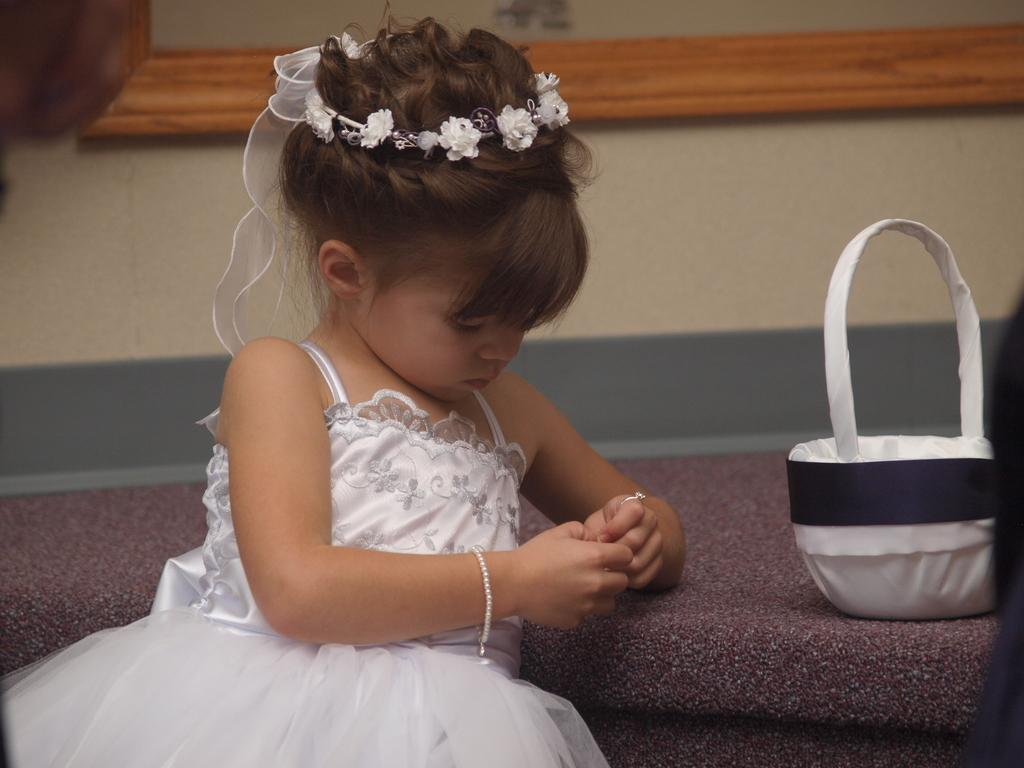What is the main subject of the image? There is a small girl in the image. Can you describe the girl's attire? The girl is wearing a white dress and has a flowers gown on her head. What type of material can be seen in the image? There is a wooden rafter visible in the image. What color is the wall in the background of the image? There is a yellow wall in the background of the image. What type of disease is the girl suffering from in the image? There is no indication of any disease in the image; the girl appears to be healthy and wearing a white dress and flowers gown. Can you tell me how many tickets the girl is holding in the image? There are no tickets present in the image; the girl is not holding any objects. 